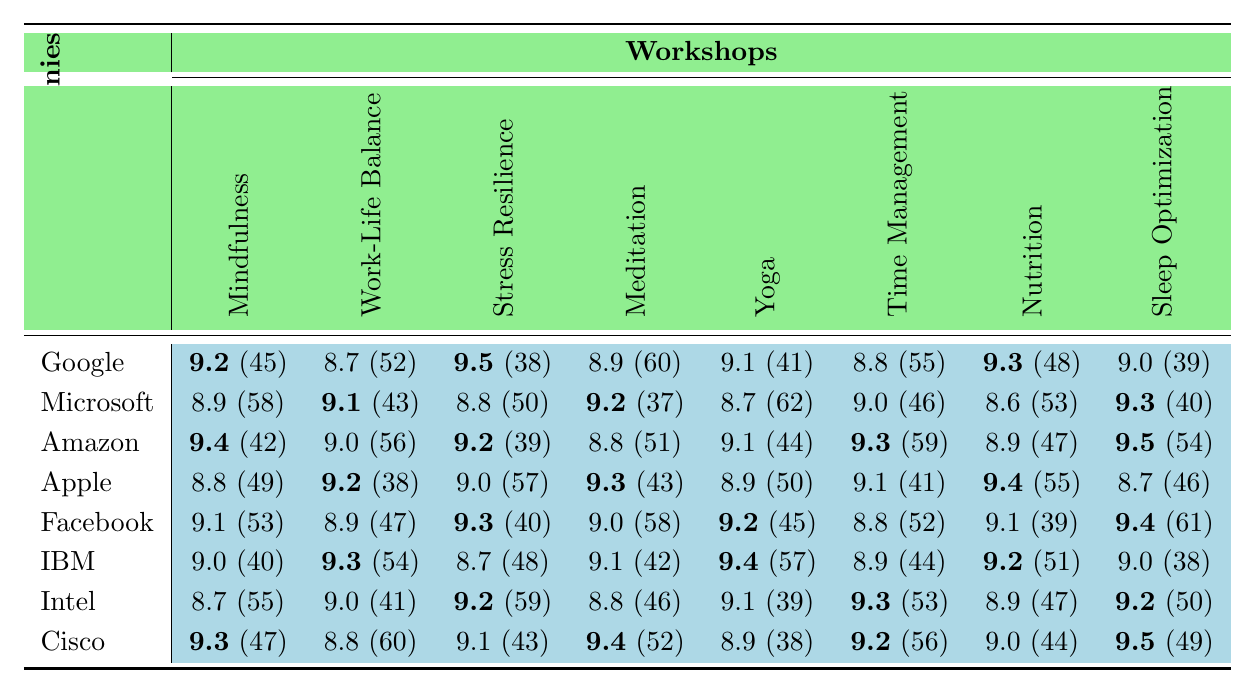What is the highest feedback score for the "Mindfulness for Executives" workshop? The highest feedback score for "Mindfulness for Executives" can be found by looking down the column for that workshop. The highest value is 9.4 from Amazon.
Answer: 9.4 Which company received the lowest score for the "Nutrition for Stress Relief" workshop? To find the lowest score for "Nutrition for Stress Relief", I compare the scores in that column. The lowest score is 8.6 from Microsoft.
Answer: 8.6 What is the average feedback score for "Sleep Optimization Seminar"? I sum the scores for the "Sleep Optimization Seminar" workshop across all companies (9.0 + 9.3 + 9.5 + 8.7 + 9.4 + 9.0 + 9.2 + 9.5 = 74.6), and divide by the number of companies (8), resulting in an average of about 9.325.
Answer: 9.325 Did Apple score higher than the average score for "Yoga for Desk Workers"? The average score for "Yoga for Desk Workers" is 9.1 (calculated from the scores in that column). Apple's score is 9.2. Since 9.2 > 9.1, Apple did score higher.
Answer: Yes Which workshop had the highest average score? I calculate the average for each workshop by summing the scores across companies and dividing by the number of companies. The highest average is for "Stress Resilience Training" with a score of 9.1 (calculated sum: 9.5 + 8.8 + 9.2 + 9.0 + 9.3 + 9.2 + 9.2 + 9.1 = 73.9, then 73.9/8 = 9.2375).
Answer: Stress Resilience Training How many participants attended the "Work-Life Balance Mastery" workshop from Intel? I find the score for the "Work-Life Balance Mastery" workshop in the Intel row. The count for this workshop is 41 participants.
Answer: 41 Which company had the highest total participant count across all workshops? First, I add the participant counts for each company. The highest total comes from Facebook with a total of 443 participants (53 + 47 + 40 + 58 + 45 + 52 + 39 + 61).
Answer: Facebook Is it true that Google had more participants than Cisco in the "Meditation for Productivity" workshop? I compare the participant counts for the "Meditation for Productivity" workshop: Google (60) vs Cisco (52). Since 60 > 52, the statement is true.
Answer: True What are the total feedback scores received by Microsoft across all workshops? I sum the feedback scores for Microsoft across all workshops: 8.9 + 9.1 + 8.8 + 9.2 + 8.7 + 9.0 + 8.6 + 9.3 = 71.6.
Answer: 71.6 Which workshop had the least participation from participants of Google? Looking at the participant counts from Google, the workshop with the least participation is "Stress Resilience Training" with 38 participants.
Answer: Stress Resilience Training 